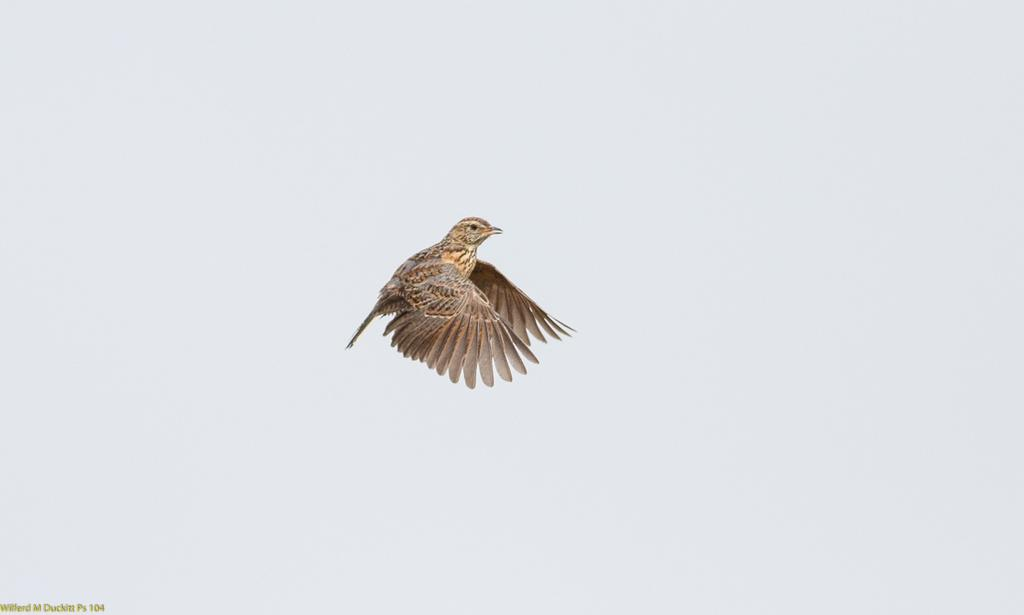What type of animal can be seen in the image? There is a bird in the image. What is the bird doing in the image? The bird is flying in the sky. What type of skirt is the bird wearing in the image? There is no skirt present in the image, as birds do not wear clothing. 